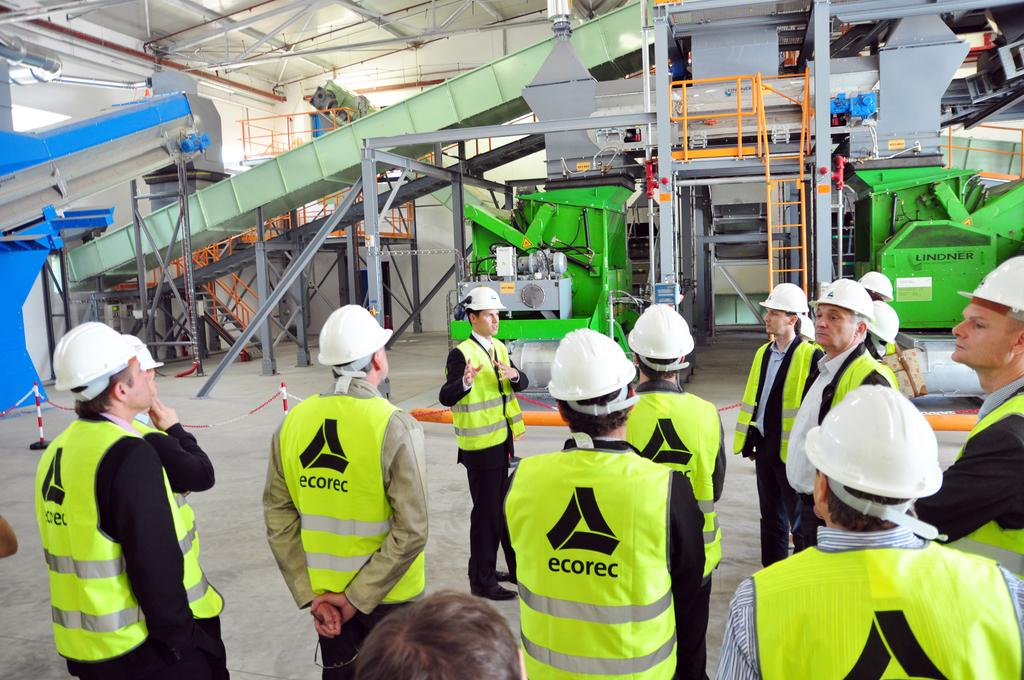How many people are in the image? There is a group of people in the image. What are the people wearing on their heads? The people are wearing helmets. What can be seen in the background of the image? There are machines, steps, a ladder, a floor, and a wall visible in the background of the image. What is present at the top of the image? There are rods visible at the top of the image. Can you tell me how the cook is helping the people in the image? There is no cook present in the image, and therefore no such interaction can be observed. 